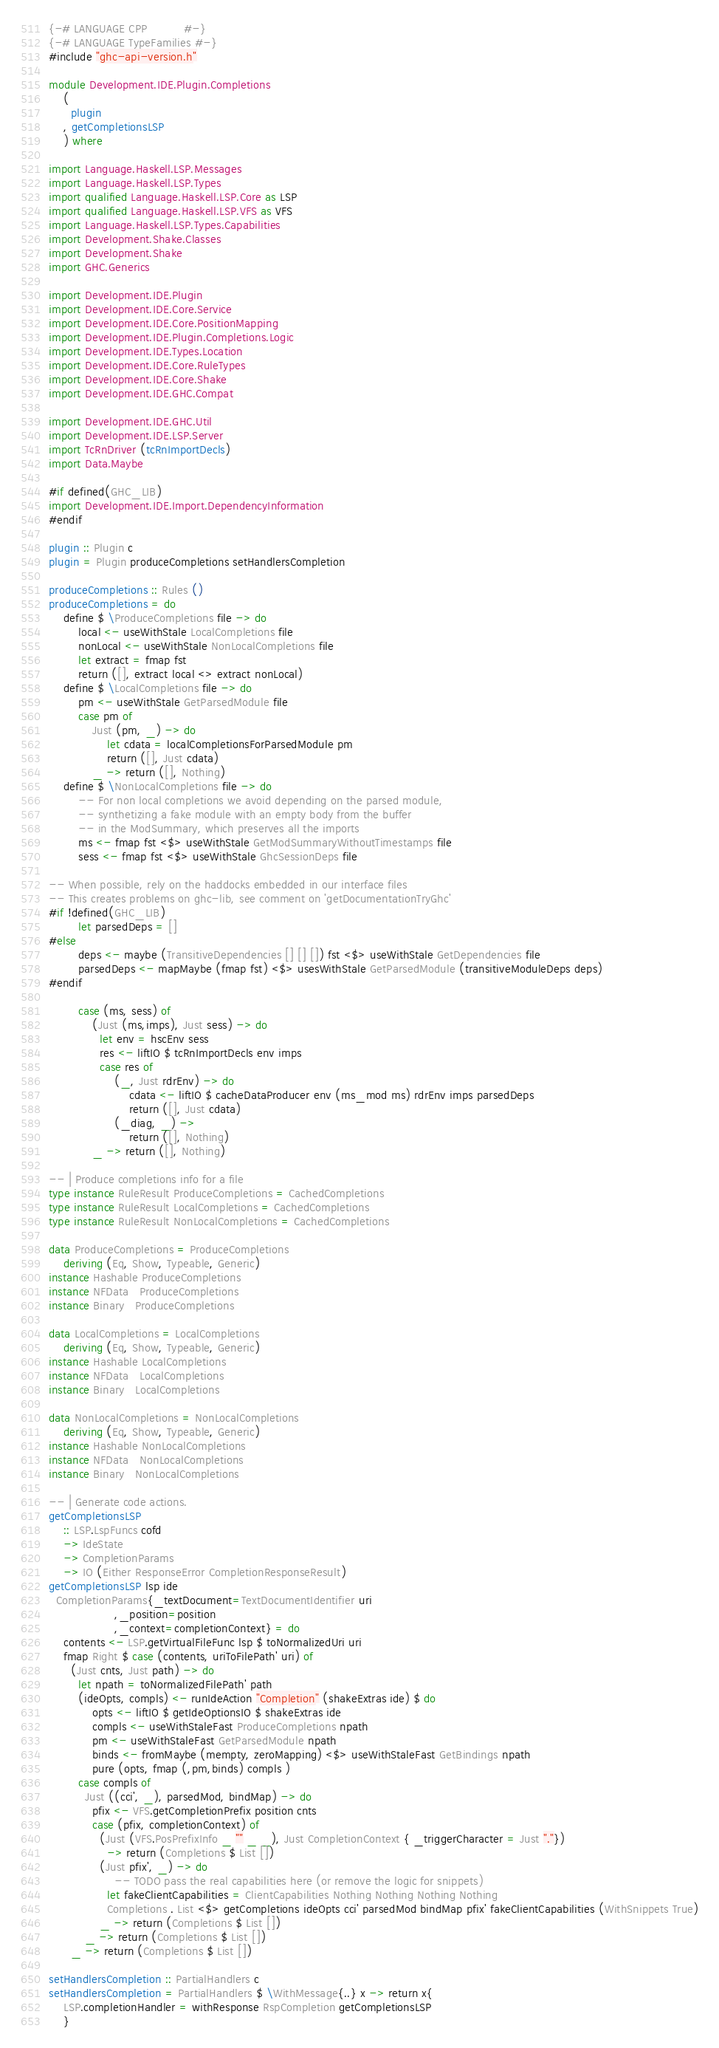Convert code to text. <code><loc_0><loc_0><loc_500><loc_500><_Haskell_>{-# LANGUAGE CPP          #-}
{-# LANGUAGE TypeFamilies #-}
#include "ghc-api-version.h"

module Development.IDE.Plugin.Completions
    (
      plugin
    , getCompletionsLSP
    ) where

import Language.Haskell.LSP.Messages
import Language.Haskell.LSP.Types
import qualified Language.Haskell.LSP.Core as LSP
import qualified Language.Haskell.LSP.VFS as VFS
import Language.Haskell.LSP.Types.Capabilities
import Development.Shake.Classes
import Development.Shake
import GHC.Generics

import Development.IDE.Plugin
import Development.IDE.Core.Service
import Development.IDE.Core.PositionMapping
import Development.IDE.Plugin.Completions.Logic
import Development.IDE.Types.Location
import Development.IDE.Core.RuleTypes
import Development.IDE.Core.Shake
import Development.IDE.GHC.Compat

import Development.IDE.GHC.Util
import Development.IDE.LSP.Server
import TcRnDriver (tcRnImportDecls)
import Data.Maybe

#if defined(GHC_LIB)
import Development.IDE.Import.DependencyInformation
#endif

plugin :: Plugin c
plugin = Plugin produceCompletions setHandlersCompletion

produceCompletions :: Rules ()
produceCompletions = do
    define $ \ProduceCompletions file -> do
        local <- useWithStale LocalCompletions file
        nonLocal <- useWithStale NonLocalCompletions file
        let extract = fmap fst
        return ([], extract local <> extract nonLocal)
    define $ \LocalCompletions file -> do
        pm <- useWithStale GetParsedModule file
        case pm of
            Just (pm, _) -> do
                let cdata = localCompletionsForParsedModule pm
                return ([], Just cdata)
            _ -> return ([], Nothing)
    define $ \NonLocalCompletions file -> do
        -- For non local completions we avoid depending on the parsed module,
        -- synthetizing a fake module with an empty body from the buffer
        -- in the ModSummary, which preserves all the imports
        ms <- fmap fst <$> useWithStale GetModSummaryWithoutTimestamps file
        sess <- fmap fst <$> useWithStale GhcSessionDeps file

-- When possible, rely on the haddocks embedded in our interface files
-- This creates problems on ghc-lib, see comment on 'getDocumentationTryGhc'
#if !defined(GHC_LIB)
        let parsedDeps = []
#else
        deps <- maybe (TransitiveDependencies [] [] []) fst <$> useWithStale GetDependencies file
        parsedDeps <- mapMaybe (fmap fst) <$> usesWithStale GetParsedModule (transitiveModuleDeps deps)
#endif

        case (ms, sess) of
            (Just (ms,imps), Just sess) -> do
              let env = hscEnv sess
              res <- liftIO $ tcRnImportDecls env imps
              case res of
                  (_, Just rdrEnv) -> do
                      cdata <- liftIO $ cacheDataProducer env (ms_mod ms) rdrEnv imps parsedDeps
                      return ([], Just cdata)
                  (_diag, _) ->
                      return ([], Nothing)
            _ -> return ([], Nothing)

-- | Produce completions info for a file
type instance RuleResult ProduceCompletions = CachedCompletions
type instance RuleResult LocalCompletions = CachedCompletions
type instance RuleResult NonLocalCompletions = CachedCompletions

data ProduceCompletions = ProduceCompletions
    deriving (Eq, Show, Typeable, Generic)
instance Hashable ProduceCompletions
instance NFData   ProduceCompletions
instance Binary   ProduceCompletions

data LocalCompletions = LocalCompletions
    deriving (Eq, Show, Typeable, Generic)
instance Hashable LocalCompletions
instance NFData   LocalCompletions
instance Binary   LocalCompletions

data NonLocalCompletions = NonLocalCompletions
    deriving (Eq, Show, Typeable, Generic)
instance Hashable NonLocalCompletions
instance NFData   NonLocalCompletions
instance Binary   NonLocalCompletions

-- | Generate code actions.
getCompletionsLSP
    :: LSP.LspFuncs cofd
    -> IdeState
    -> CompletionParams
    -> IO (Either ResponseError CompletionResponseResult)
getCompletionsLSP lsp ide
  CompletionParams{_textDocument=TextDocumentIdentifier uri
                  ,_position=position
                  ,_context=completionContext} = do
    contents <- LSP.getVirtualFileFunc lsp $ toNormalizedUri uri
    fmap Right $ case (contents, uriToFilePath' uri) of
      (Just cnts, Just path) -> do
        let npath = toNormalizedFilePath' path
        (ideOpts, compls) <- runIdeAction "Completion" (shakeExtras ide) $ do
            opts <- liftIO $ getIdeOptionsIO $ shakeExtras ide
            compls <- useWithStaleFast ProduceCompletions npath
            pm <- useWithStaleFast GetParsedModule npath
            binds <- fromMaybe (mempty, zeroMapping) <$> useWithStaleFast GetBindings npath
            pure (opts, fmap (,pm,binds) compls )
        case compls of
          Just ((cci', _), parsedMod, bindMap) -> do
            pfix <- VFS.getCompletionPrefix position cnts
            case (pfix, completionContext) of
              (Just (VFS.PosPrefixInfo _ "" _ _), Just CompletionContext { _triggerCharacter = Just "."})
                -> return (Completions $ List [])
              (Just pfix', _) -> do
                  -- TODO pass the real capabilities here (or remove the logic for snippets)
                let fakeClientCapabilities = ClientCapabilities Nothing Nothing Nothing Nothing
                Completions . List <$> getCompletions ideOpts cci' parsedMod bindMap pfix' fakeClientCapabilities (WithSnippets True)
              _ -> return (Completions $ List [])
          _ -> return (Completions $ List [])
      _ -> return (Completions $ List [])

setHandlersCompletion :: PartialHandlers c
setHandlersCompletion = PartialHandlers $ \WithMessage{..} x -> return x{
    LSP.completionHandler = withResponse RspCompletion getCompletionsLSP
    }
</code> 